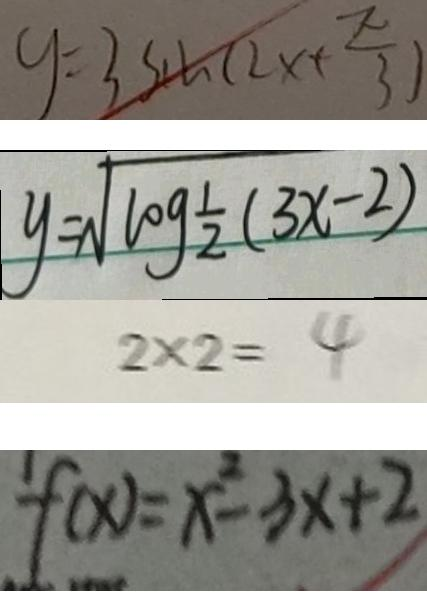Convert formula to latex. <formula><loc_0><loc_0><loc_500><loc_500>y = 3 \sin ( 2 x + \frac { \pi } { 3 } ) 
 y = \sqrt { \log \frac { 1 } { 2 } ( 3 x - 2 ) } 
 2 \times 2 = 4 
 f ( x ) = x ^ { 2 } - 3 x + 2</formula> 